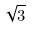Convert formula to latex. <formula><loc_0><loc_0><loc_500><loc_500>\sqrt { 3 }</formula> 